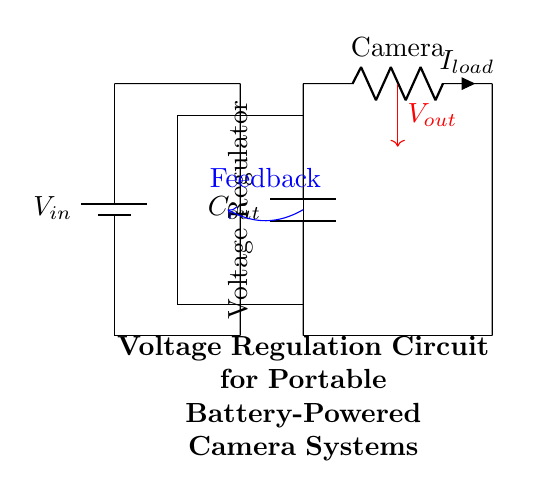What is the input voltage of the circuit? The input voltage, labeled as V_in, is represented in the circuit. It is typically the voltage provided by the battery.
Answer: V_in What component is used for voltage regulation? The component in the circuit specifically designed to regulate voltage is the rectangle labeled "Voltage Regulator."
Answer: Voltage Regulator What is the role of the capacitor labeled C_out? The capacitor labeled C_out is connected to the output and serves to stabilize the output voltage by smoothing out fluctuations.
Answer: Stabilizing What is the current flowing to the load referred to as? The current flowing to the load, which is the camera in this circuit, is labeled as I_load.
Answer: I_load How does feedback function in this circuit? Feedback is drawn as a blue arrow indicating that it returns from the output of the circuit to the voltage regulator, which helps to maintain a consistent output voltage.
Answer: Maintains stability What is the output voltage represented as? The output voltage is depicted by the red arrow labeled V_out, indicating the voltage available to the load (camera).
Answer: V_out What type of load does this circuit supply? The load depicted in the circuit is labeled as Camera, indicating a portable device powered by this regulation circuit.
Answer: Camera 